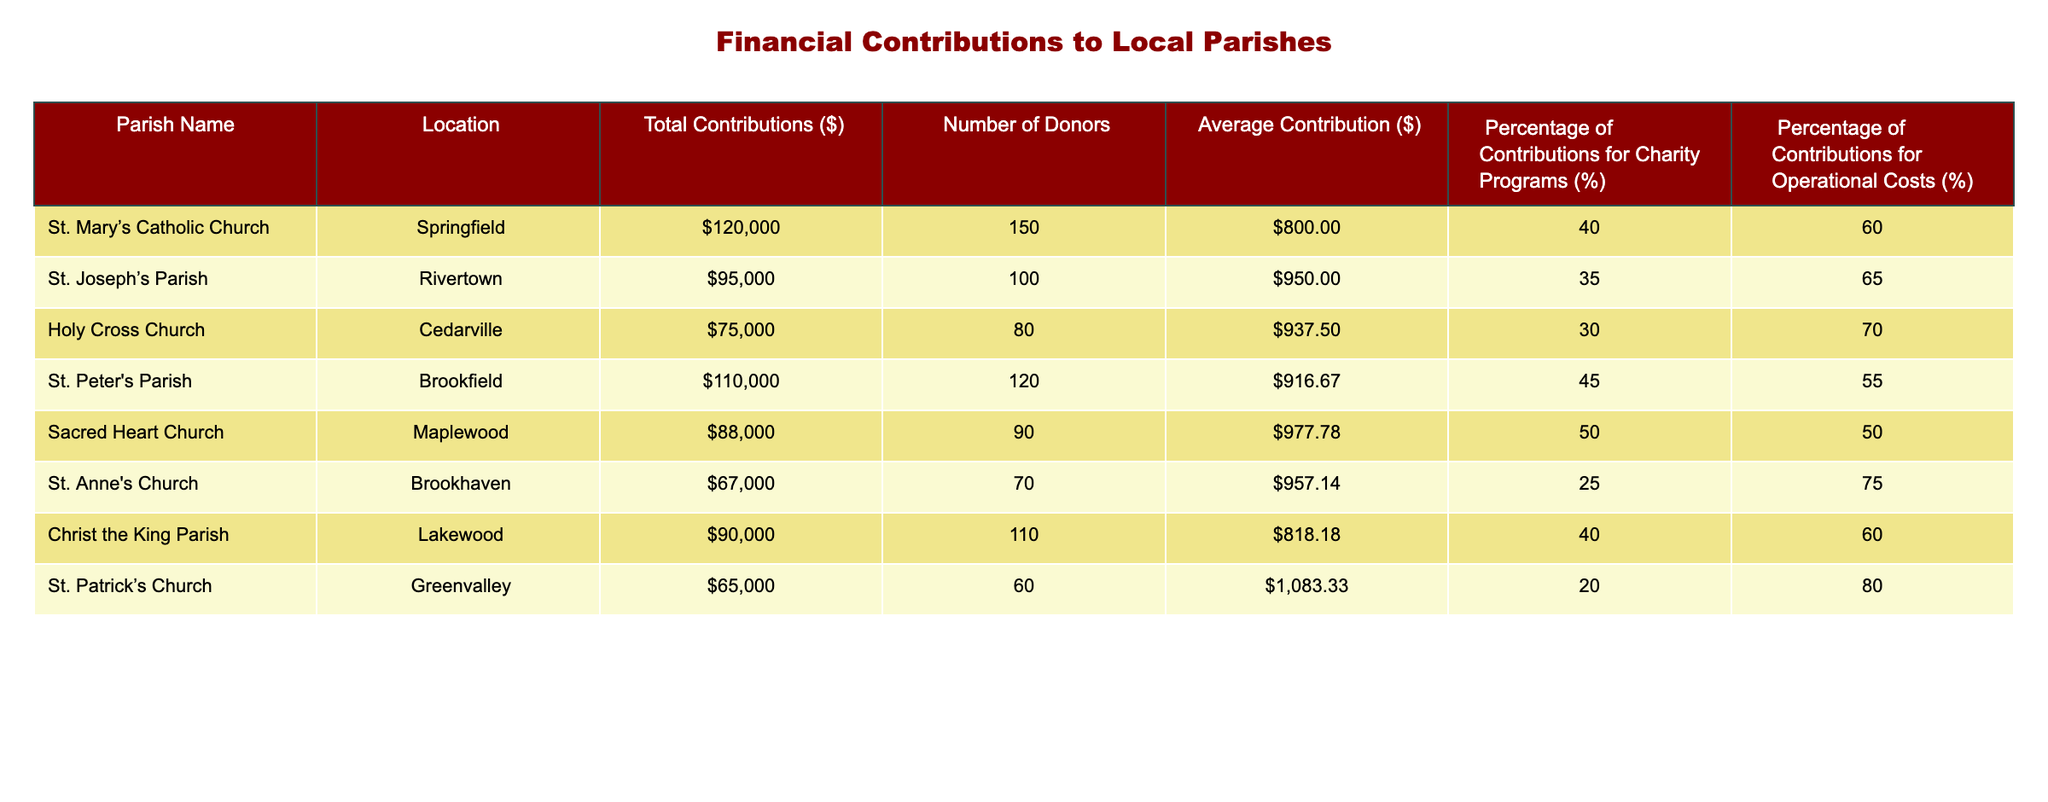What is the total contribution amount for St. Mary’s Catholic Church? The table shows that the total contribution for St. Mary’s Catholic Church is listed directly under the "Total Contributions ($)" column. It indicates $120,000.
Answer: 120000 Which parish has the highest average contribution per donor? The table indicates that St. Patrick’s Church has the highest average contribution per donor, calculated by dividing the total contributions ($65,000) by the number of donors (60), resulting in an average contribution of approximately $1,083.33. Checking all average contributions, St. Patrick’s has the highest figure.
Answer: 1083.33 What percentage of contributions for St. Peter's Parish is allocated for charity programs? According to the table, St. Peter's Parish allocates 45% of its contributions to charity programs, as listed in the "Percentage of Contributions for Charity Programs (%)" column.
Answer: 45 Does St. Joseph’s Parish have a higher percentage for operational costs than St. Mary’s Catholic Church? The table reveals that St. Joseph's Parish allocates 65% of its contributions for operational costs, while St. Mary's allocates 60%. Since 65% is higher than 60%, the answer is yes.
Answer: Yes What is the difference in total contributions between Sacred Heart Church and Holy Cross Church? Sacred Heart Church has total contributions of $88,000, while Holy Cross Church’s contributions amount to $75,000. The difference is calculated by subtracting the latter from the former: $88,000 - $75,000 = $13,000.
Answer: 13000 If we take the average contribution across all listed parishes, what would it be? To find the average contribution, we first sum the total contributions for all parishes: $120,000 + $95,000 + $75,000 + $110,000 + $88,000 + $67,000 + $90,000 + $65,000 = $840,000. We then divide this sum by the number of parishes (8), resulting in an average of $840,000 / 8 = $105,000.
Answer: 105000 How many parishes allocate less than 35% of their contributions to charity programs? By examining the table, we see that St. Anne’s Church (25%), Holy Cross Church (30%), and St. Patrick’s Church (20%) all allocate less than 35% to charity. There are three parishes under this threshold.
Answer: 3 Is there a parish that has exactly 50% of contributions directed towards operational costs? The table shows that Sacred Heart Church allocates 50% of its contributions towards operational costs. Therefore, the response to this question is yes.
Answer: Yes 